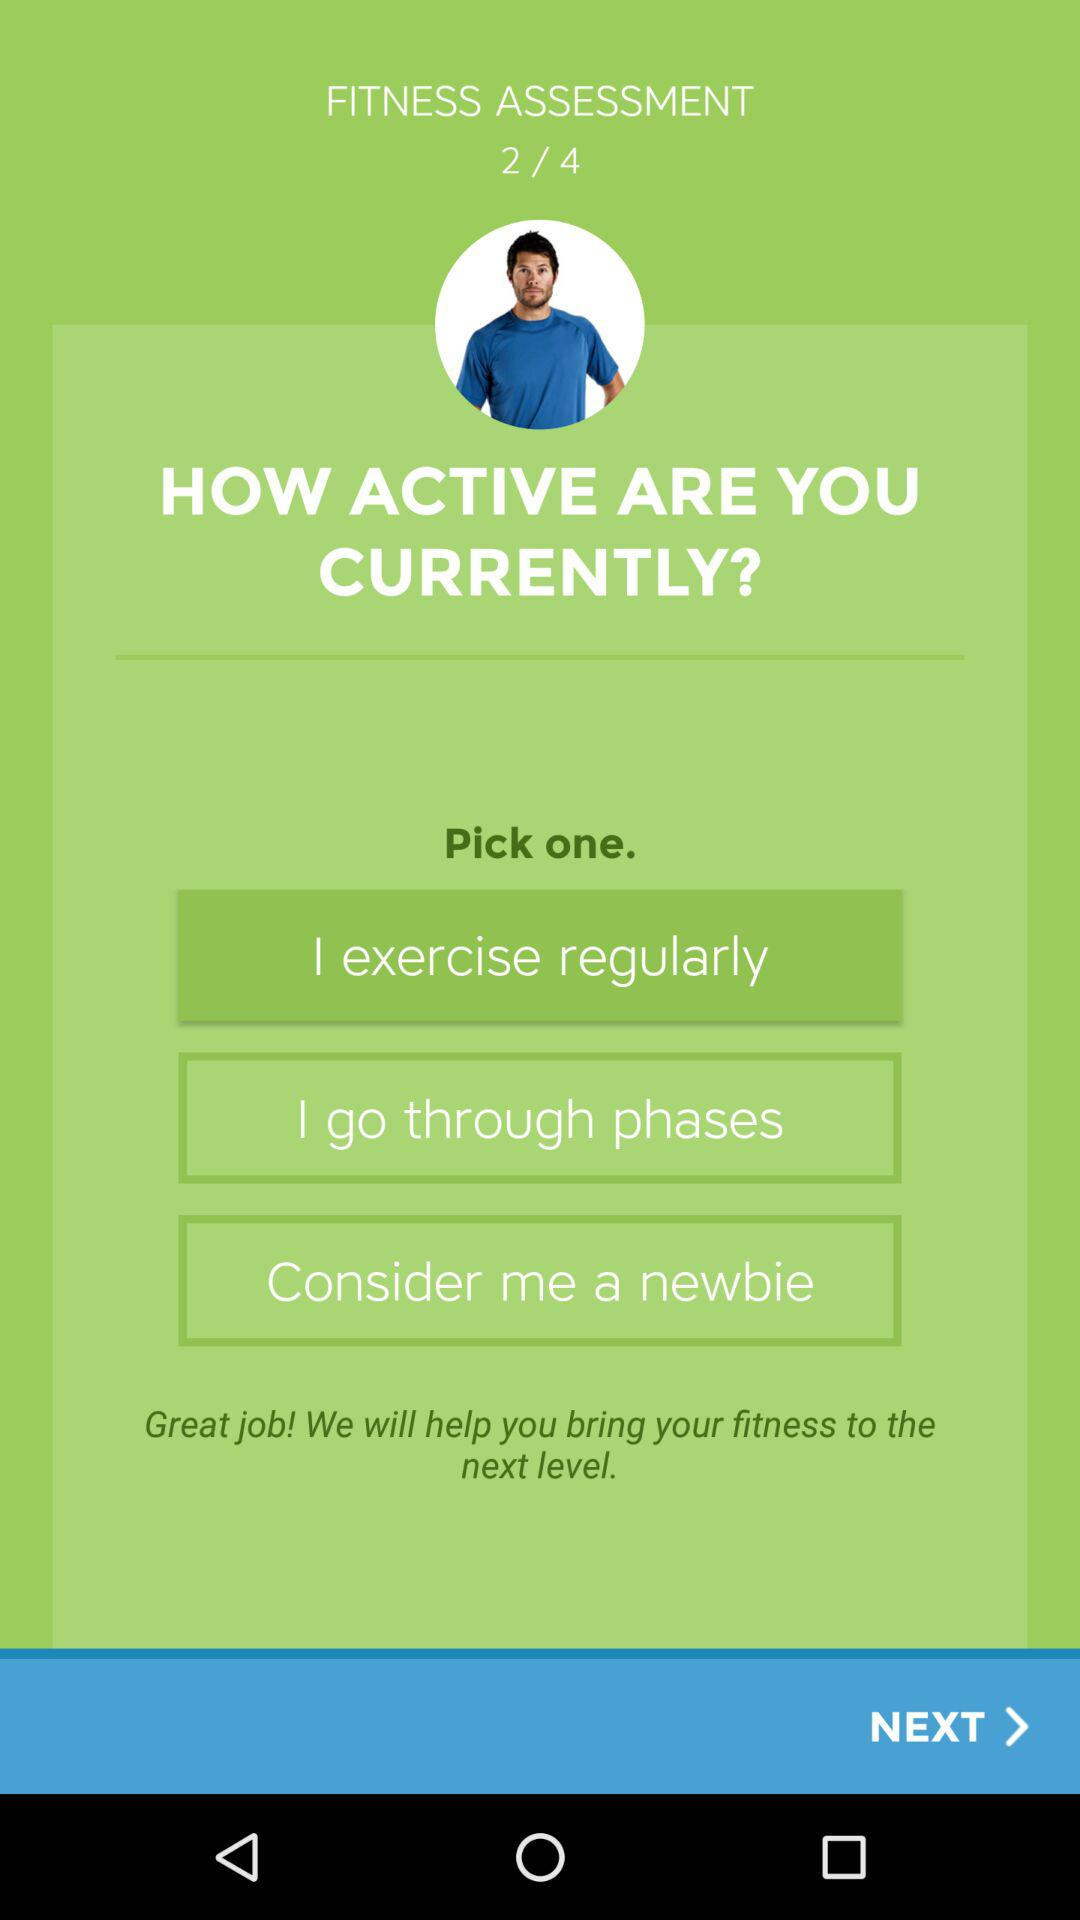Which answer is selected? The selected answer is "I exercise regularly". 